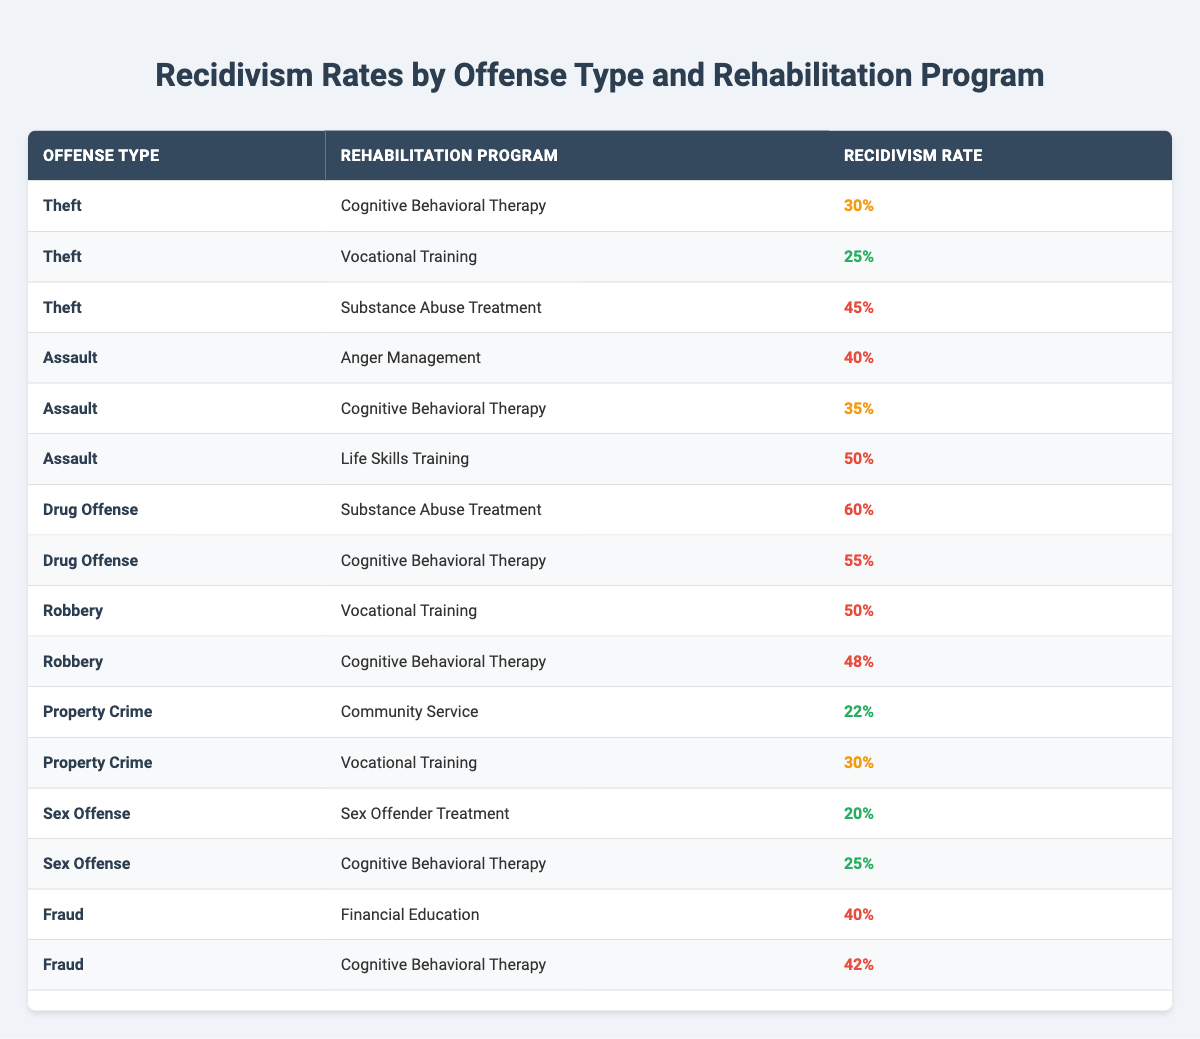What is the recidivism rate for Theft with Vocational Training? The table shows that the recidivism rate for Theft with Vocational Training is 25%.
Answer: 25% Which offense type has the highest recidivism rate in Cognitive Behavioral Therapy? Looking at the table, Drug Offense has a recidivism rate of 55% under Cognitive Behavioral Therapy, which is the highest among all offense types with that program.
Answer: Drug Offense What are the recidivism rates for Assault with Anger Management and Life Skills Training? The recidivism rate for Assault with Anger Management is 40%, and for Life Skills Training, it is 50%.
Answer: 40% and 50% Is the recidivism rate for Fraud with Financial Education higher than for Theft with Cognitive Behavioral Therapy? The recidivism rate for Fraud with Financial Education is 40%, while for Theft with Cognitive Behavioral Therapy it is 30%. Since 40% is greater than 30%, the statement is true.
Answer: Yes What is the average recidivism rate of Property Crime across both rehabilitation programs? Property Crime has a recidivism rate of 22% with Community Service and 30% with Vocational Training. Calculating the average: (22 + 30) / 2 = 26%.
Answer: 26% Which rehabilitation program corresponds to the lowest recidivism rate, and what is that rate? The table shows that the Sex Offender Treatment has the lowest recidivism rate of 20%.
Answer: 20% How does the recidivism rate for Theft with Substance Abuse Treatment compare to that of Drug Offense with Cognitive Behavioral Therapy? The recidivism rate for Theft with Substance Abuse Treatment is 45%, while for Drug Offense with Cognitive Behavioral Therapy it is 55%. Thus, Theft’s rate is lower than that for Drug Offense.
Answer: Lower What is the difference in recidivism rates between the highest for Assault and the lowest for Sex Offense? The highest recidivism rate for Assault with Life Skills Training is 50%, and the lowest for Sex Offense with Sex Offender Treatment is 20%. The difference is 50% - 20% = 30%.
Answer: 30% Based on the data, does Cognitive Behavioral Therapy generally result in higher or lower recidivism rates compared to Vocational Training? Looking at the table, Cognitive Behavioral Therapy tends to have higher rates (for Theft 30% vs. 25%, Assault 35% vs. 50%, Drug Offense 55% vs. 60% for the equivalent programs). Thus, it generally results in higher recidivism rates compared to Vocational Training.
Answer: Higher What is the total recidivism rate for all Drug Offense rehabilitation programs combined? The recidivism rates for Drug Offense are 60% (Substance Abuse Treatment) and 55% (Cognitive Behavioral Therapy). Adding them gives 60% + 55% = 115%.
Answer: 115% 